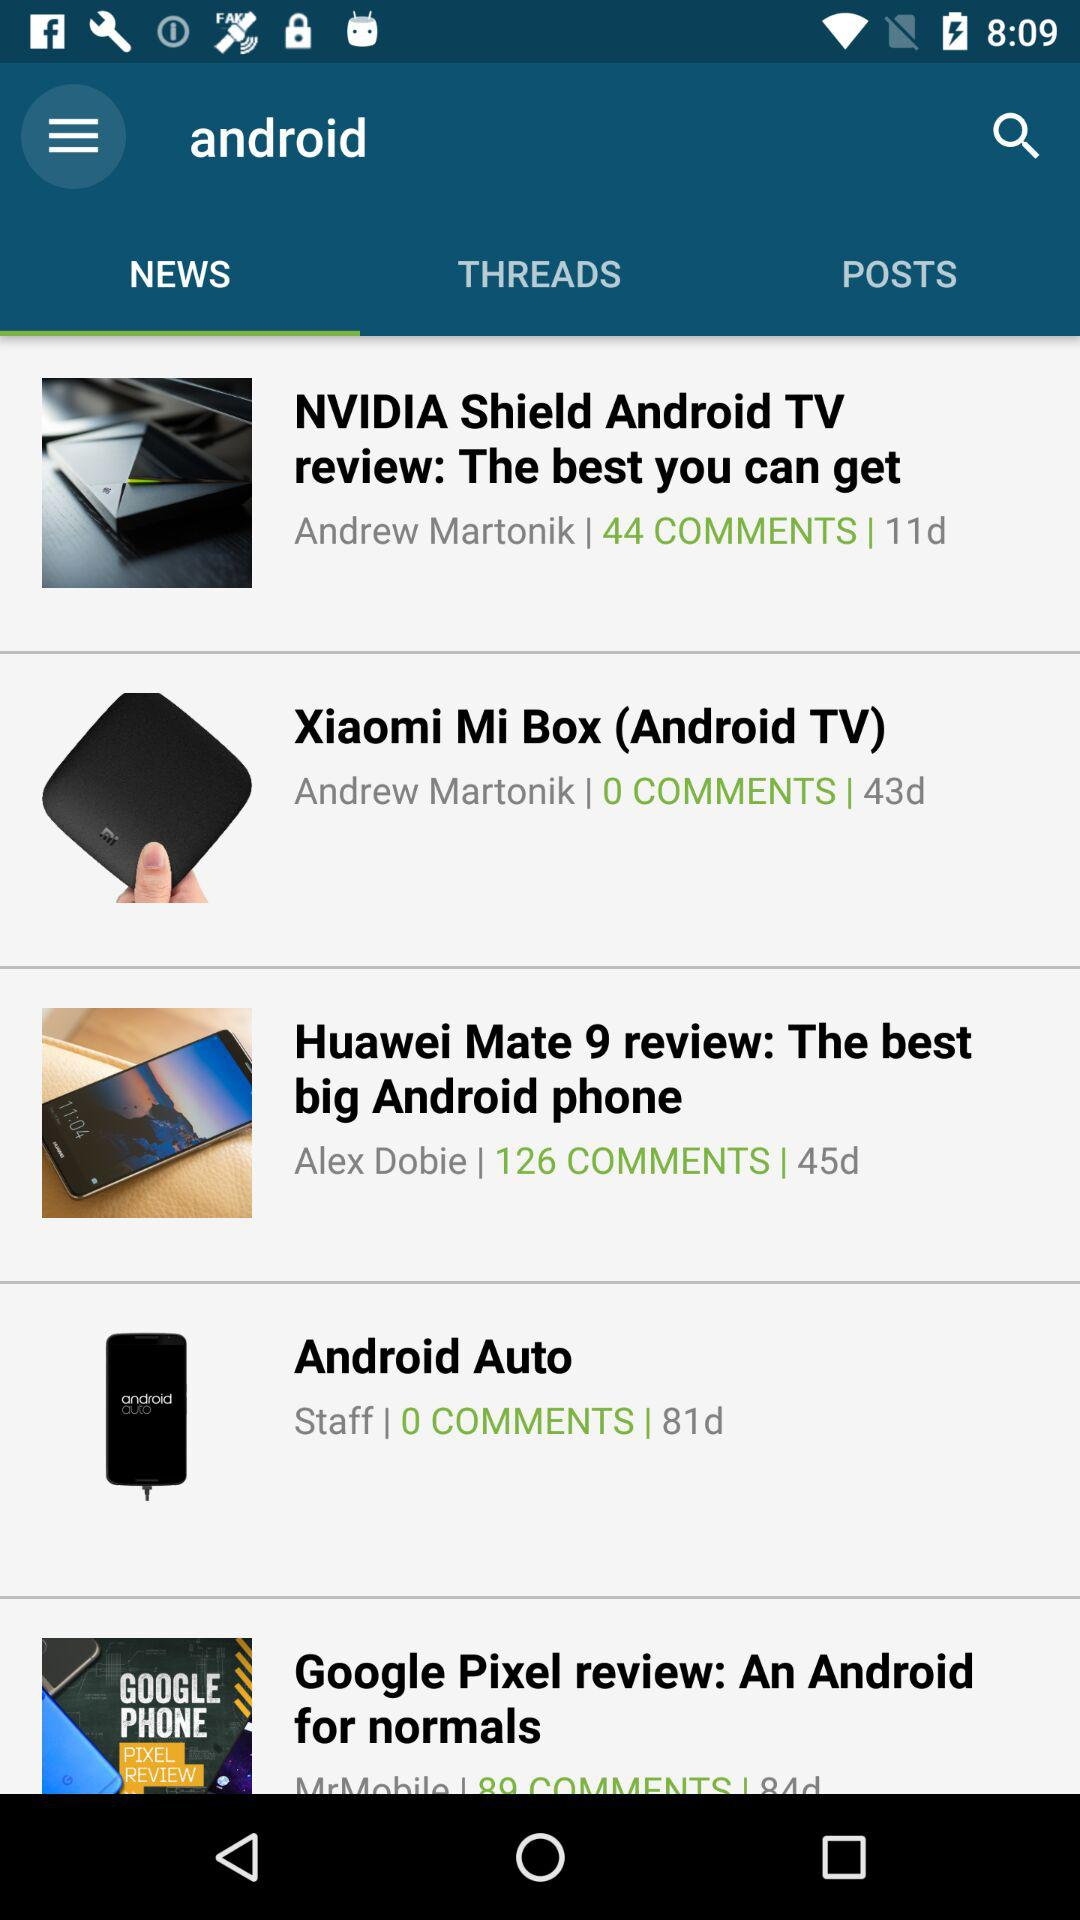How many more comments does the Huawei Mate 9 review have than the Xiaomi Mi Box review?
Answer the question using a single word or phrase. 126 